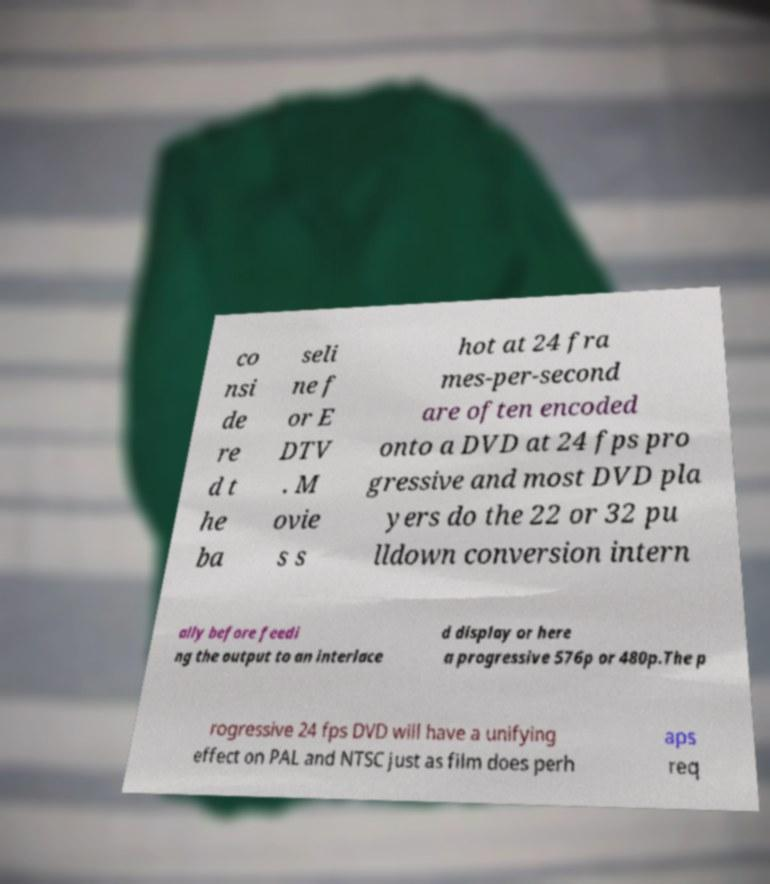Could you extract and type out the text from this image? co nsi de re d t he ba seli ne f or E DTV . M ovie s s hot at 24 fra mes-per-second are often encoded onto a DVD at 24 fps pro gressive and most DVD pla yers do the 22 or 32 pu lldown conversion intern ally before feedi ng the output to an interlace d display or here a progressive 576p or 480p.The p rogressive 24 fps DVD will have a unifying effect on PAL and NTSC just as film does perh aps req 